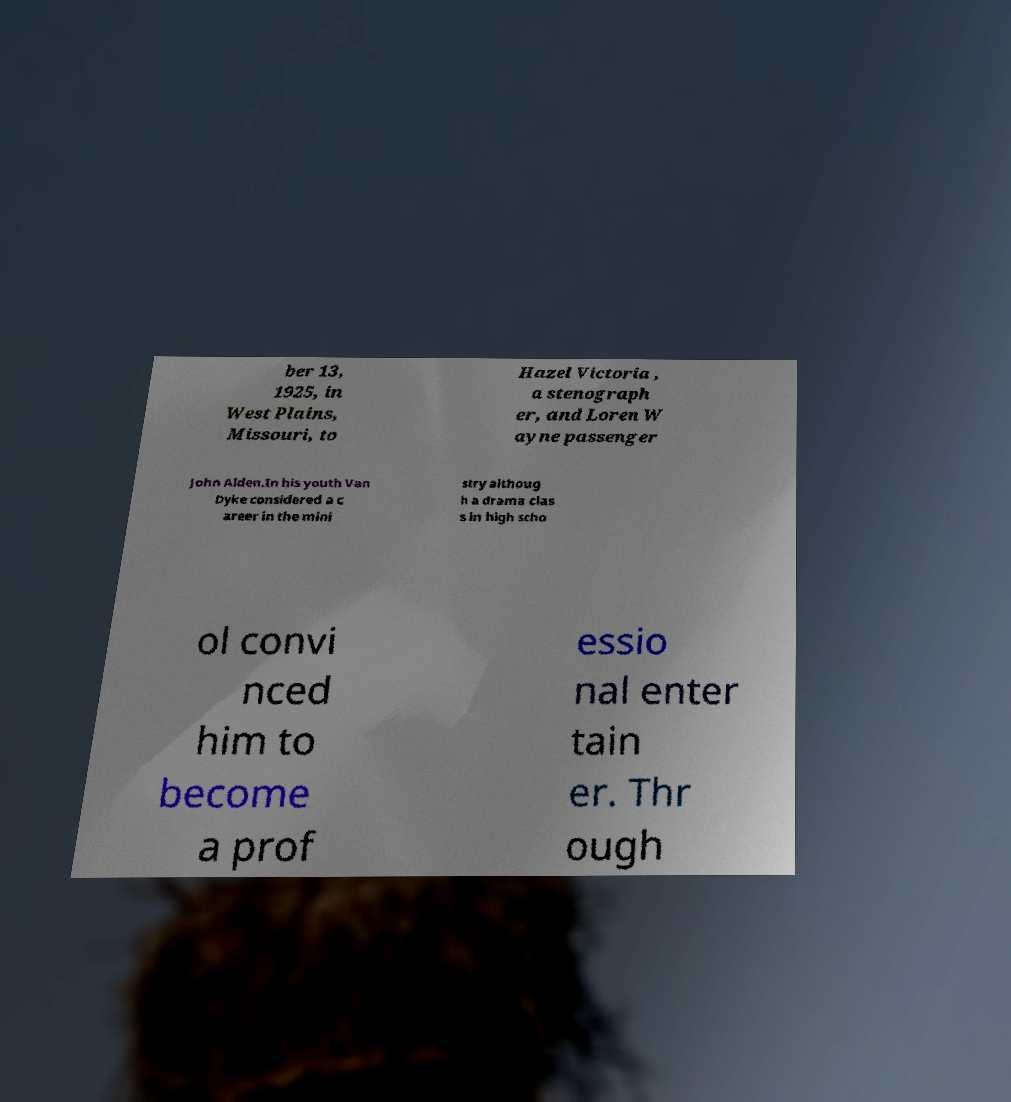Could you assist in decoding the text presented in this image and type it out clearly? ber 13, 1925, in West Plains, Missouri, to Hazel Victoria , a stenograph er, and Loren W ayne passenger John Alden.In his youth Van Dyke considered a c areer in the mini stry althoug h a drama clas s in high scho ol convi nced him to become a prof essio nal enter tain er. Thr ough 